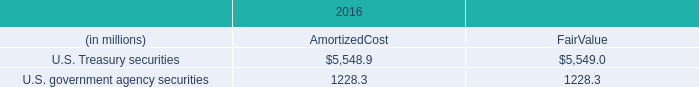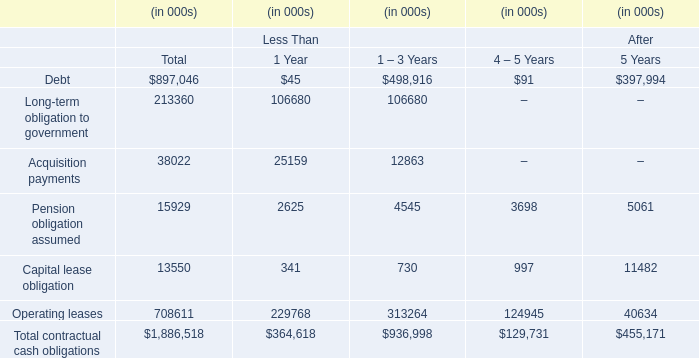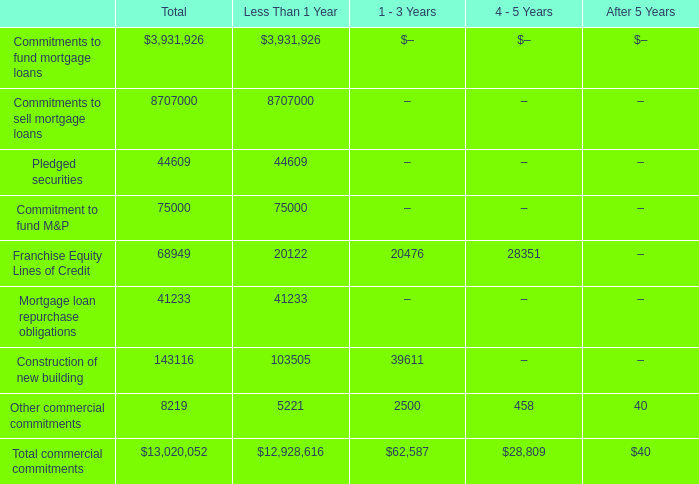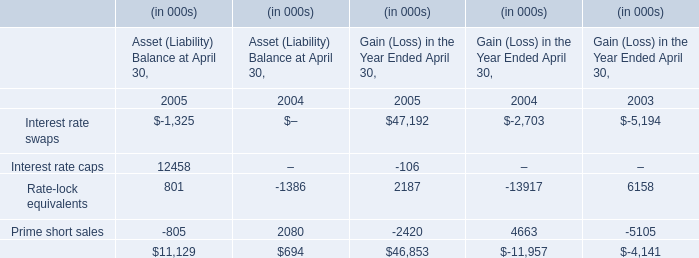Which section is Franchise Equity Lines of Credit the highest? 
Answer: 1 - 3 Years. 